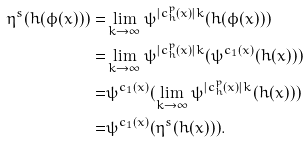<formula> <loc_0><loc_0><loc_500><loc_500>\eta ^ { s } ( h ( \phi ( x ) ) ) = & \lim _ { k \to { \infty } } \psi ^ { | c _ { h } ^ { p } ( x ) | k } ( h ( \phi ( x ) ) ) \\ = & \lim _ { k \to { \infty } } \psi ^ { | c _ { h } ^ { p } ( x ) | k } ( \psi ^ { c _ { 1 } ( x ) } ( h ( x ) ) ) \\ = & \psi ^ { c _ { 1 } ( x ) } ( \lim _ { k \to { \infty } } \psi ^ { | c _ { h } ^ { p } ( x ) | k } ( h ( x ) ) ) \\ = & \psi ^ { c _ { 1 } ( x ) } ( \eta ^ { s } ( h ( x ) ) ) .</formula> 